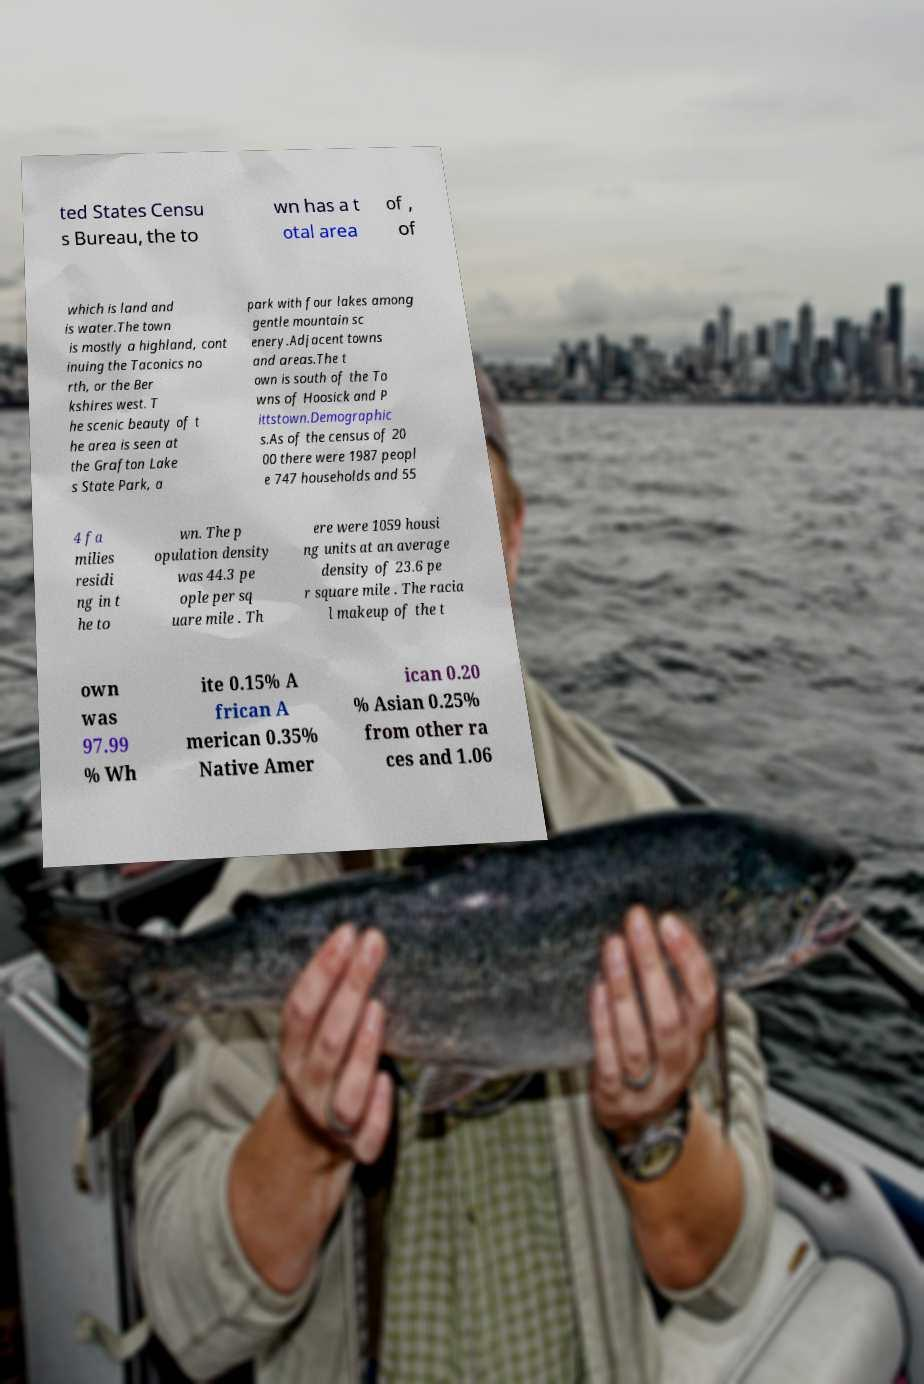Can you accurately transcribe the text from the provided image for me? ted States Censu s Bureau, the to wn has a t otal area of , of which is land and is water.The town is mostly a highland, cont inuing the Taconics no rth, or the Ber kshires west. T he scenic beauty of t he area is seen at the Grafton Lake s State Park, a park with four lakes among gentle mountain sc enery.Adjacent towns and areas.The t own is south of the To wns of Hoosick and P ittstown.Demographic s.As of the census of 20 00 there were 1987 peopl e 747 households and 55 4 fa milies residi ng in t he to wn. The p opulation density was 44.3 pe ople per sq uare mile . Th ere were 1059 housi ng units at an average density of 23.6 pe r square mile . The racia l makeup of the t own was 97.99 % Wh ite 0.15% A frican A merican 0.35% Native Amer ican 0.20 % Asian 0.25% from other ra ces and 1.06 